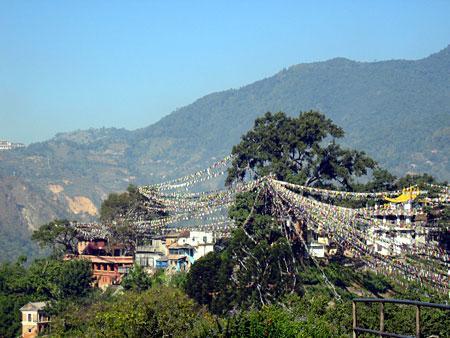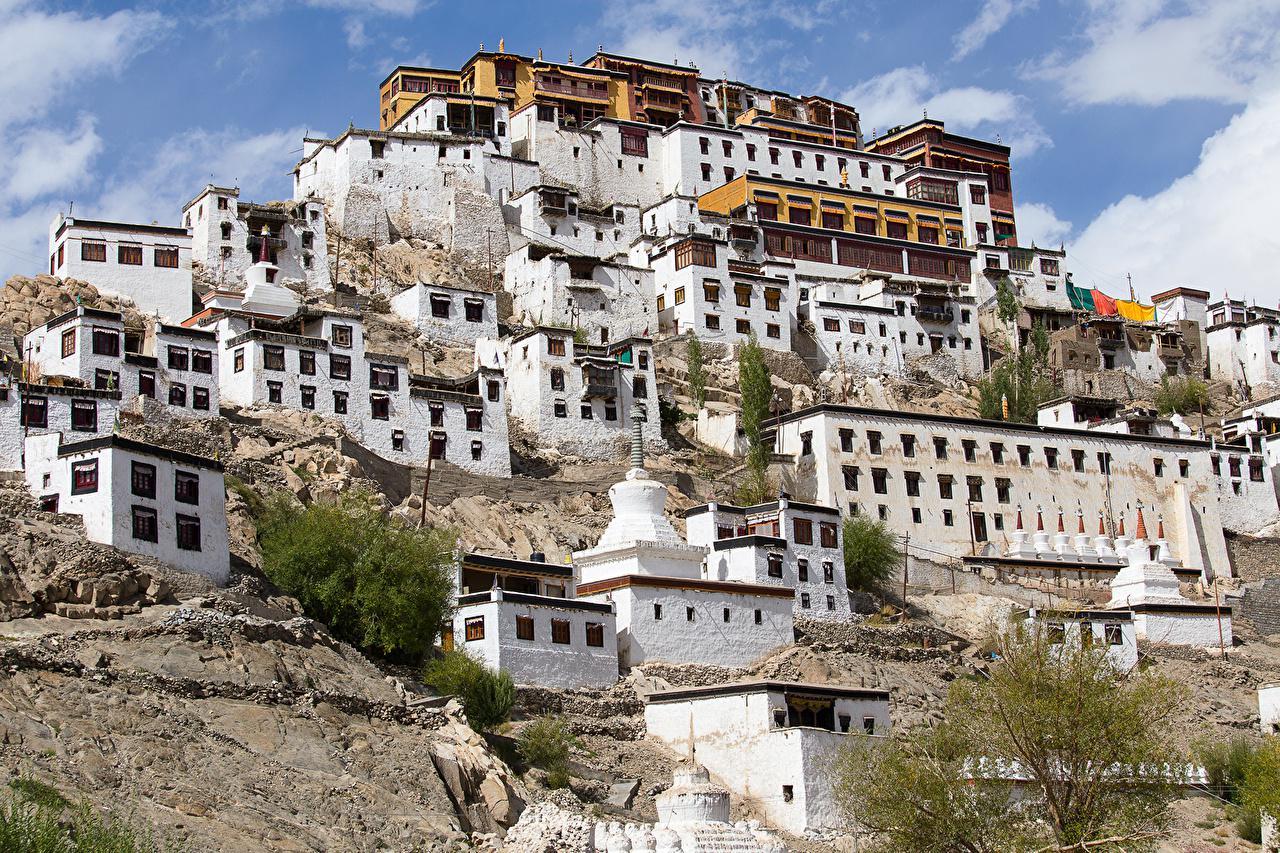The first image is the image on the left, the second image is the image on the right. Examine the images to the left and right. Is the description "In at least one image there is at least ten white house under a yellow house." accurate? Answer yes or no. Yes. The first image is the image on the left, the second image is the image on the right. Examine the images to the left and right. Is the description "Some roofs are green." accurate? Answer yes or no. No. 